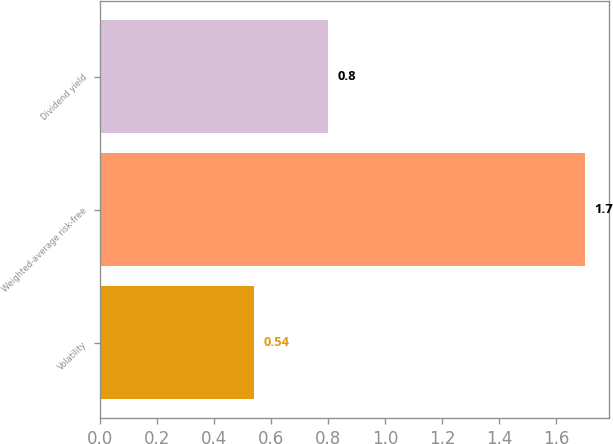Convert chart to OTSL. <chart><loc_0><loc_0><loc_500><loc_500><bar_chart><fcel>Volatility<fcel>Weighted-average risk-free<fcel>Dividend yield<nl><fcel>0.54<fcel>1.7<fcel>0.8<nl></chart> 